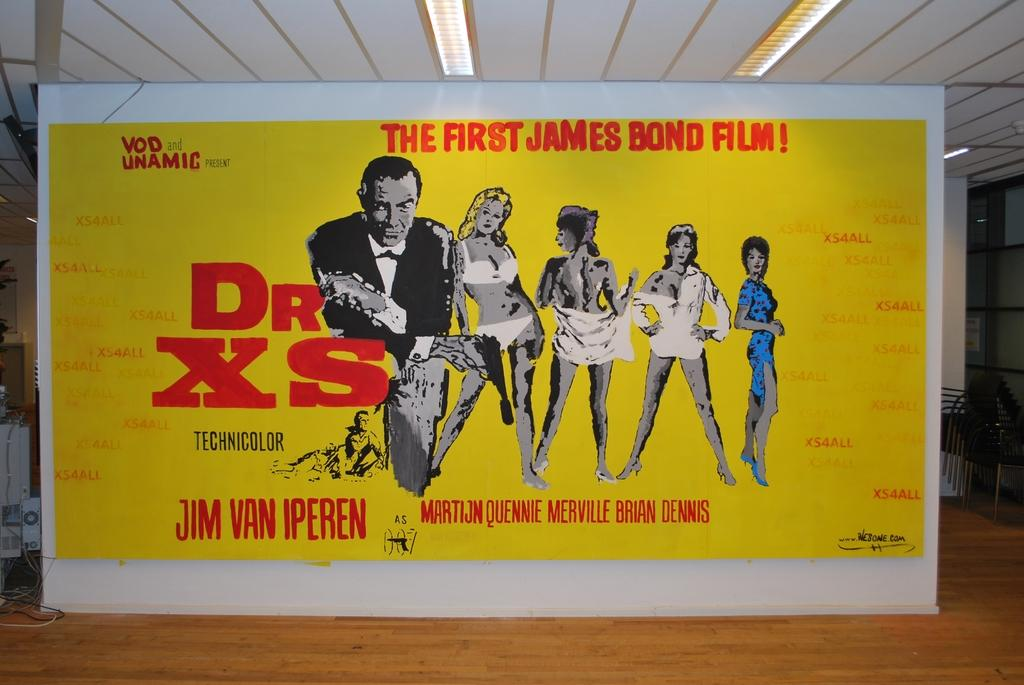<image>
Give a short and clear explanation of the subsequent image. A sign announcing The First James Bond Film Dr XS 